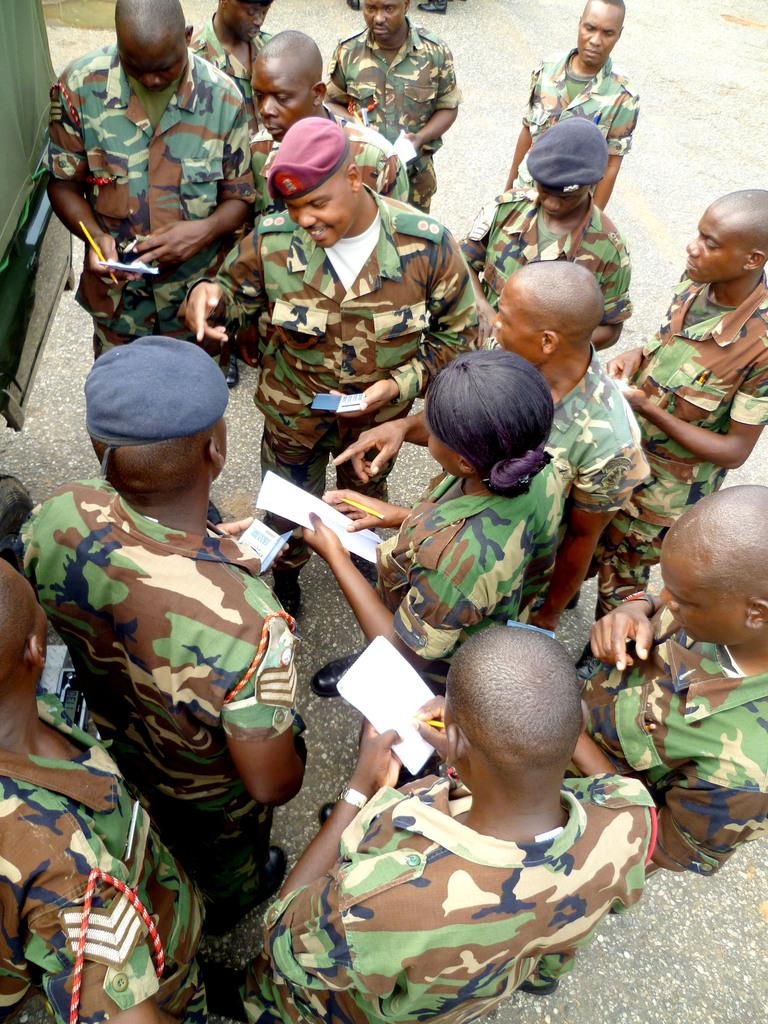What are the people doing in the image? The persons standing on the road are holding objects. Can you describe the objects they are holding? Unfortunately, the specific objects cannot be identified from the given facts. What else is present on the road in the image? There is a vehicle on the road. Can you see any yaks grazing on the celery in the image? There is no mention of yaks or celery in the image, so this scenario is not present. 